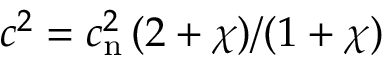Convert formula to latex. <formula><loc_0><loc_0><loc_500><loc_500>c ^ { 2 } = c _ { n } ^ { 2 } \, ( 2 + \chi ) / ( 1 + \chi )</formula> 